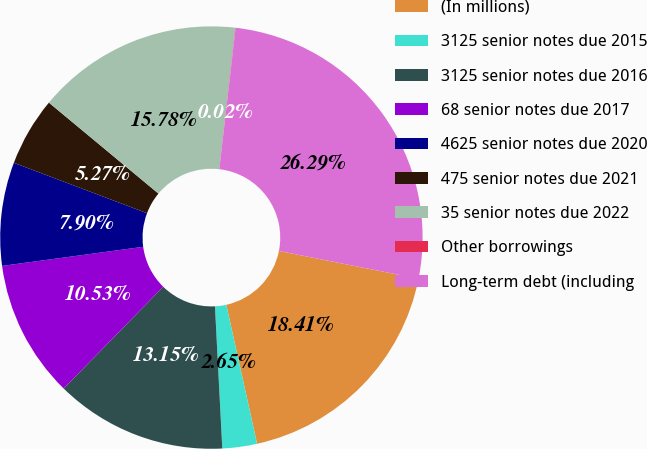<chart> <loc_0><loc_0><loc_500><loc_500><pie_chart><fcel>(In millions)<fcel>3125 senior notes due 2015<fcel>3125 senior notes due 2016<fcel>68 senior notes due 2017<fcel>4625 senior notes due 2020<fcel>475 senior notes due 2021<fcel>35 senior notes due 2022<fcel>Other borrowings<fcel>Long-term debt (including<nl><fcel>18.41%<fcel>2.65%<fcel>13.15%<fcel>10.53%<fcel>7.9%<fcel>5.27%<fcel>15.78%<fcel>0.02%<fcel>26.29%<nl></chart> 